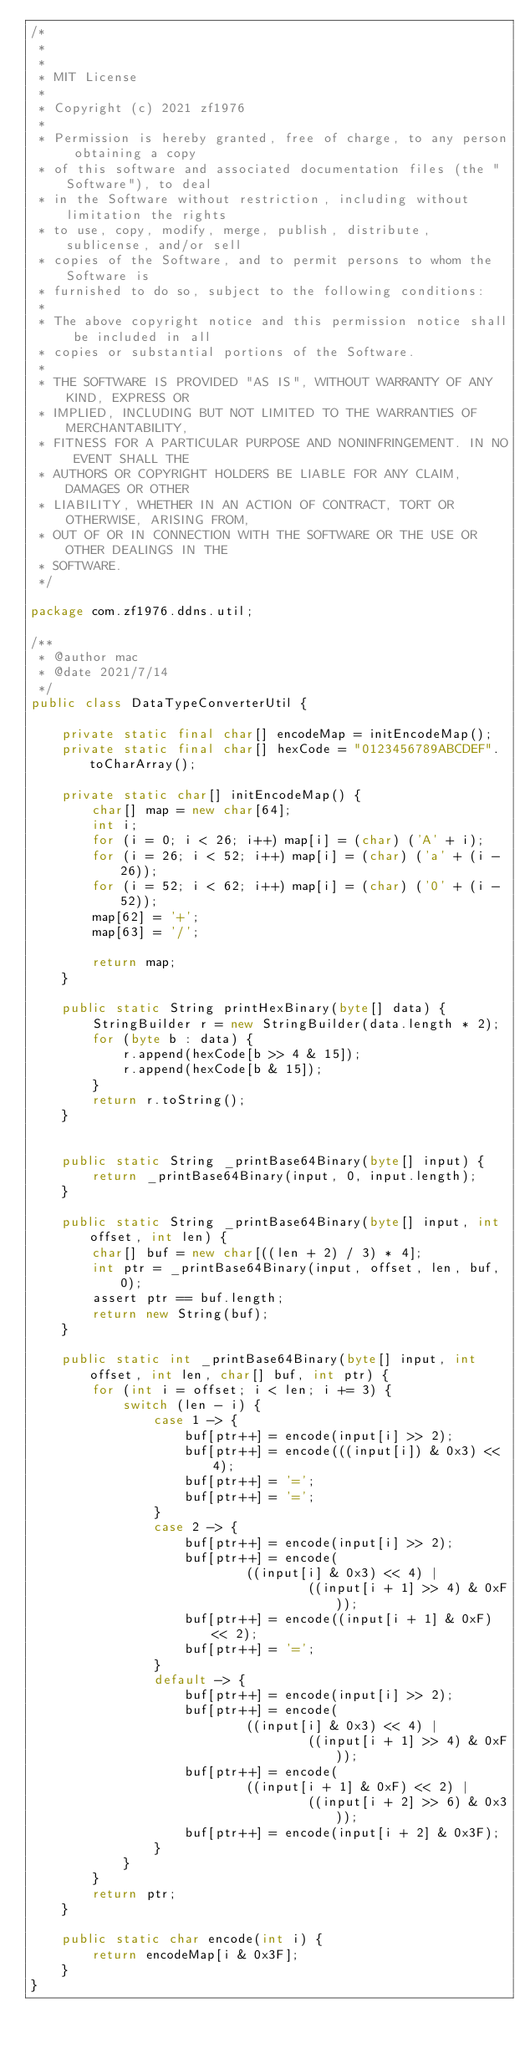<code> <loc_0><loc_0><loc_500><loc_500><_Java_>/*
 *
 *
 * MIT License
 *
 * Copyright (c) 2021 zf1976
 *
 * Permission is hereby granted, free of charge, to any person obtaining a copy
 * of this software and associated documentation files (the "Software"), to deal
 * in the Software without restriction, including without limitation the rights
 * to use, copy, modify, merge, publish, distribute, sublicense, and/or sell
 * copies of the Software, and to permit persons to whom the Software is
 * furnished to do so, subject to the following conditions:
 *
 * The above copyright notice and this permission notice shall be included in all
 * copies or substantial portions of the Software.
 *
 * THE SOFTWARE IS PROVIDED "AS IS", WITHOUT WARRANTY OF ANY KIND, EXPRESS OR
 * IMPLIED, INCLUDING BUT NOT LIMITED TO THE WARRANTIES OF MERCHANTABILITY,
 * FITNESS FOR A PARTICULAR PURPOSE AND NONINFRINGEMENT. IN NO EVENT SHALL THE
 * AUTHORS OR COPYRIGHT HOLDERS BE LIABLE FOR ANY CLAIM, DAMAGES OR OTHER
 * LIABILITY, WHETHER IN AN ACTION OF CONTRACT, TORT OR OTHERWISE, ARISING FROM,
 * OUT OF OR IN CONNECTION WITH THE SOFTWARE OR THE USE OR OTHER DEALINGS IN THE
 * SOFTWARE.
 */

package com.zf1976.ddns.util;

/**
 * @author mac
 * @date 2021/7/14
 */
public class DataTypeConverterUtil {

    private static final char[] encodeMap = initEncodeMap();
    private static final char[] hexCode = "0123456789ABCDEF".toCharArray();

    private static char[] initEncodeMap() {
        char[] map = new char[64];
        int i;
        for (i = 0; i < 26; i++) map[i] = (char) ('A' + i);
        for (i = 26; i < 52; i++) map[i] = (char) ('a' + (i - 26));
        for (i = 52; i < 62; i++) map[i] = (char) ('0' + (i - 52));
        map[62] = '+';
        map[63] = '/';

        return map;
    }

    public static String printHexBinary(byte[] data) {
        StringBuilder r = new StringBuilder(data.length * 2);
        for (byte b : data) {
            r.append(hexCode[b >> 4 & 15]);
            r.append(hexCode[b & 15]);
        }
        return r.toString();
    }


    public static String _printBase64Binary(byte[] input) {
        return _printBase64Binary(input, 0, input.length);
    }

    public static String _printBase64Binary(byte[] input, int offset, int len) {
        char[] buf = new char[((len + 2) / 3) * 4];
        int ptr = _printBase64Binary(input, offset, len, buf, 0);
        assert ptr == buf.length;
        return new String(buf);
    }

    public static int _printBase64Binary(byte[] input, int offset, int len, char[] buf, int ptr) {
        for (int i = offset; i < len; i += 3) {
            switch (len - i) {
                case 1 -> {
                    buf[ptr++] = encode(input[i] >> 2);
                    buf[ptr++] = encode(((input[i]) & 0x3) << 4);
                    buf[ptr++] = '=';
                    buf[ptr++] = '=';
                }
                case 2 -> {
                    buf[ptr++] = encode(input[i] >> 2);
                    buf[ptr++] = encode(
                            ((input[i] & 0x3) << 4) |
                                    ((input[i + 1] >> 4) & 0xF));
                    buf[ptr++] = encode((input[i + 1] & 0xF) << 2);
                    buf[ptr++] = '=';
                }
                default -> {
                    buf[ptr++] = encode(input[i] >> 2);
                    buf[ptr++] = encode(
                            ((input[i] & 0x3) << 4) |
                                    ((input[i + 1] >> 4) & 0xF));
                    buf[ptr++] = encode(
                            ((input[i + 1] & 0xF) << 2) |
                                    ((input[i + 2] >> 6) & 0x3));
                    buf[ptr++] = encode(input[i + 2] & 0x3F);
                }
            }
        }
        return ptr;
    }

    public static char encode(int i) {
        return encodeMap[i & 0x3F];
    }
}
</code> 